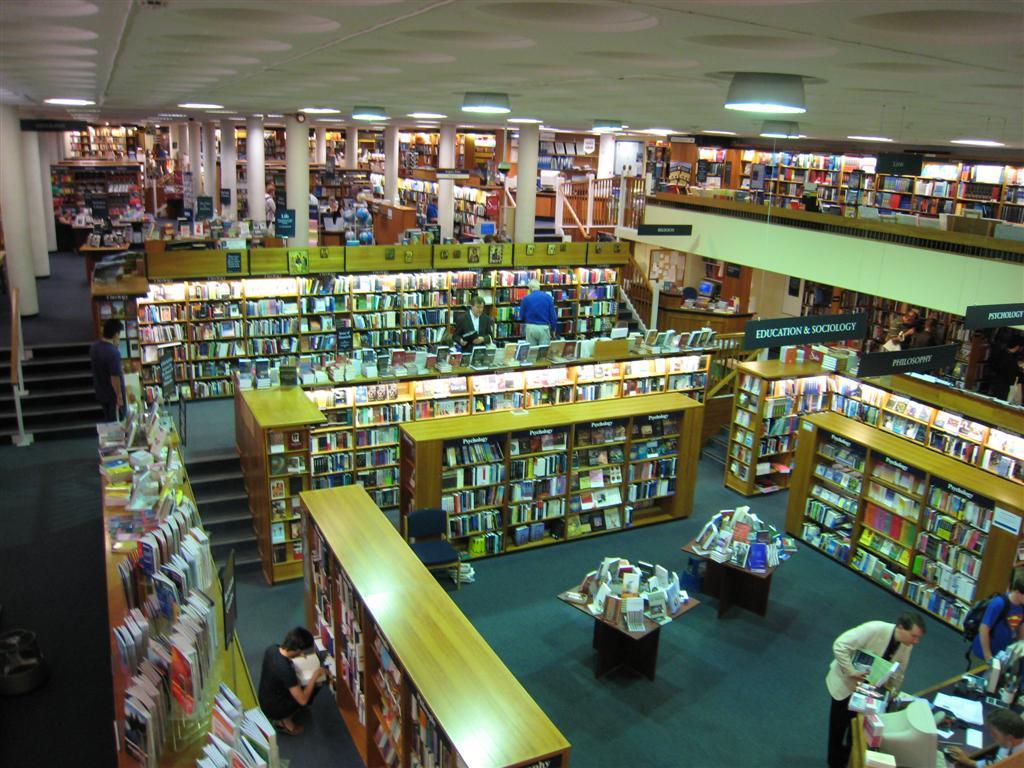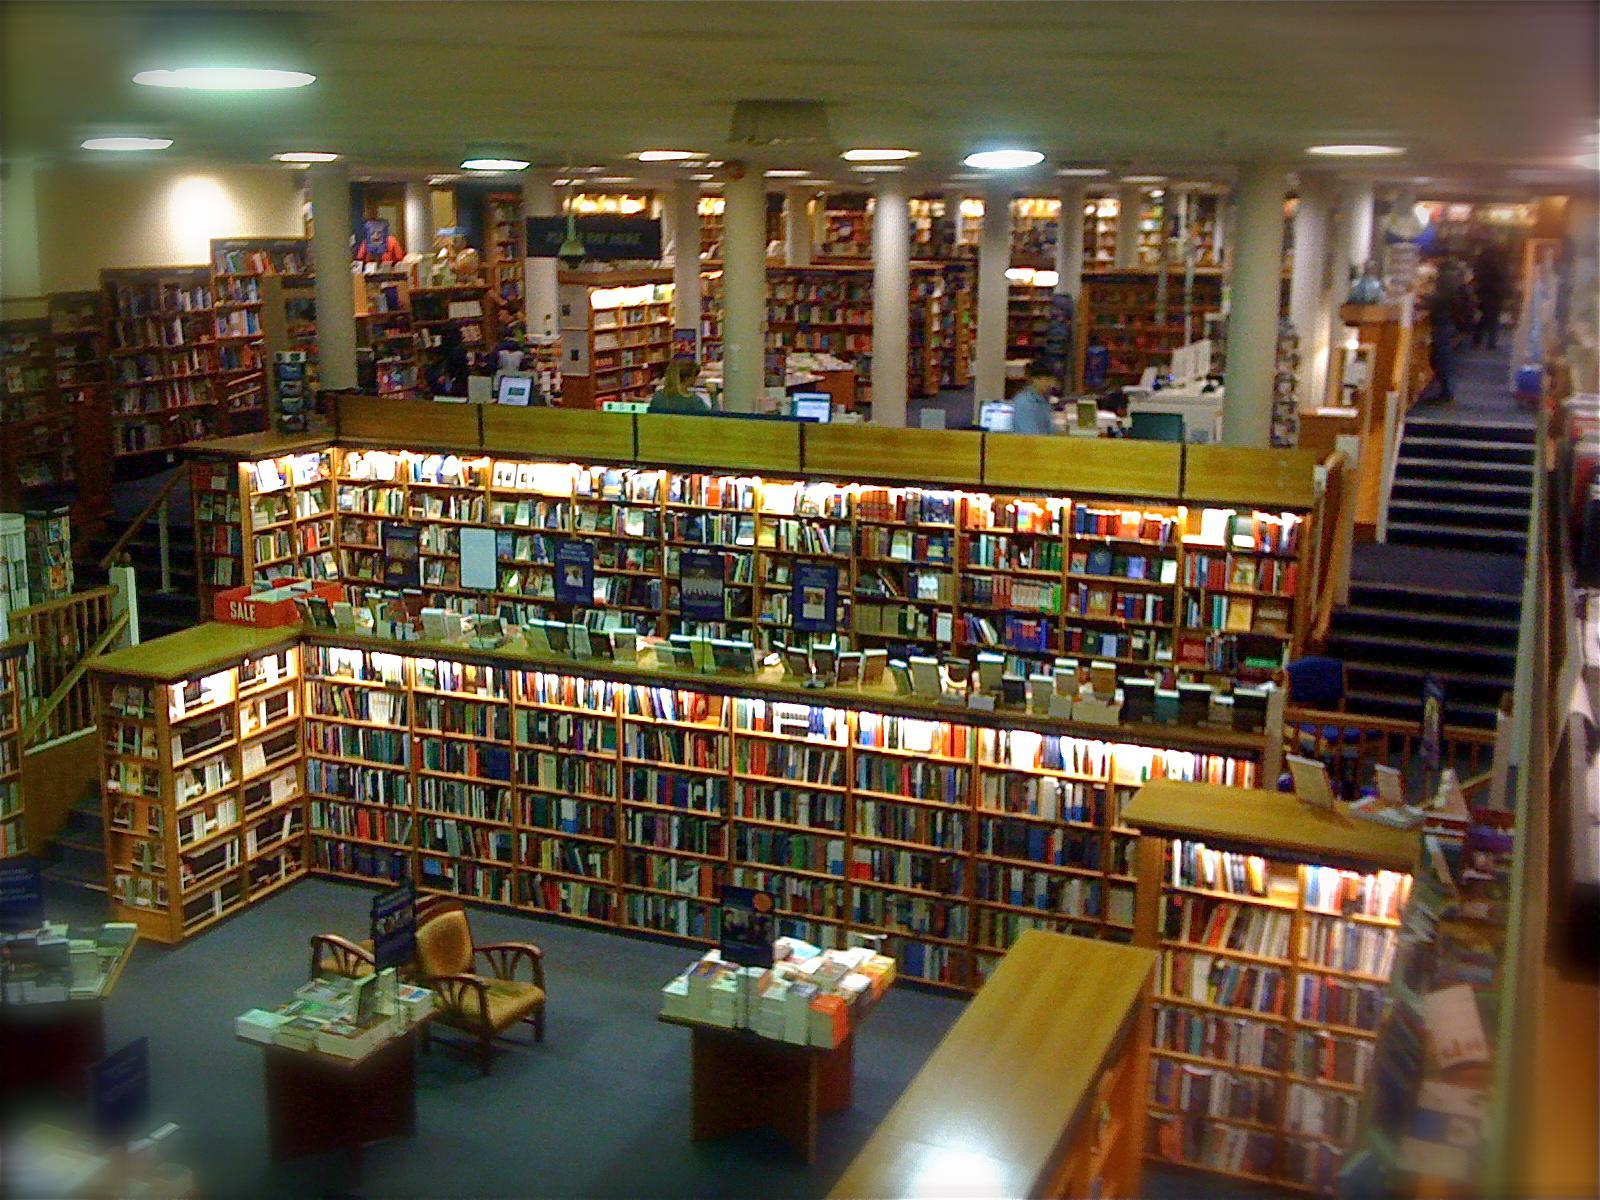The first image is the image on the left, the second image is the image on the right. Analyze the images presented: Is the assertion "the book store is being viewed from the second floor" valid? Answer yes or no. Yes. The first image is the image on the left, the second image is the image on the right. Assess this claim about the two images: "One image is a bookstore interior featuring bright red-orange on the wall above black bookshelves, and a sculptural red-orange furniture piece in front of the shelves.". Correct or not? Answer yes or no. No. 